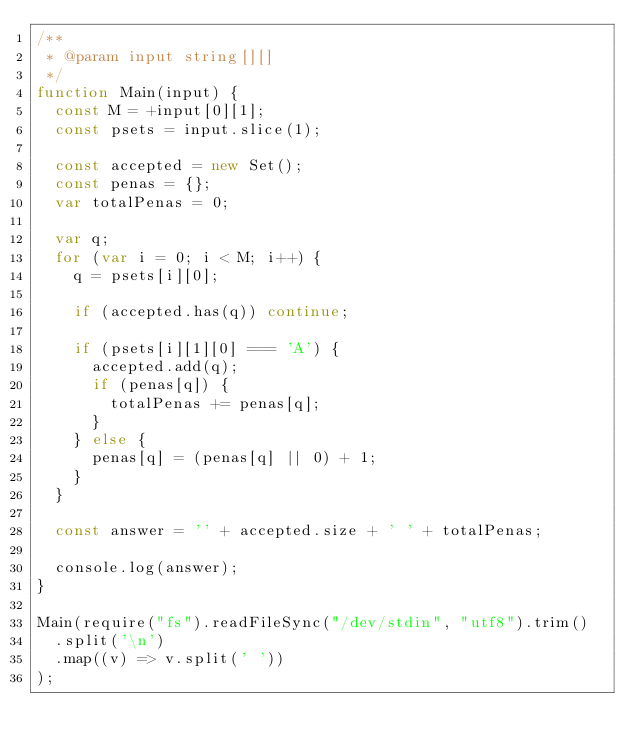<code> <loc_0><loc_0><loc_500><loc_500><_JavaScript_>/**
 * @param input string[][]
 */
function Main(input) {
  const M = +input[0][1];
  const psets = input.slice(1);

  const accepted = new Set();
  const penas = {};
  var totalPenas = 0;

  var q;
  for (var i = 0; i < M; i++) {
    q = psets[i][0];

    if (accepted.has(q)) continue;

    if (psets[i][1][0] === 'A') {
      accepted.add(q);
      if (penas[q]) {
        totalPenas += penas[q];
      }
    } else {
      penas[q] = (penas[q] || 0) + 1;
    }
  }

  const answer = '' + accepted.size + ' ' + totalPenas;

  console.log(answer);
}

Main(require("fs").readFileSync("/dev/stdin", "utf8").trim()
  .split('\n')
  .map((v) => v.split(' '))
);
</code> 